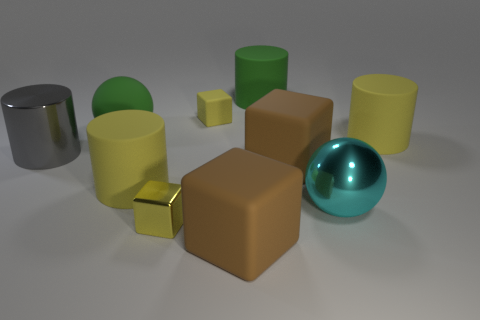How many objects in the image have a reflective surface? There are three objects in the image with a reflective surface: a silver cylinder, a green cylinder, and a teal sphere. 